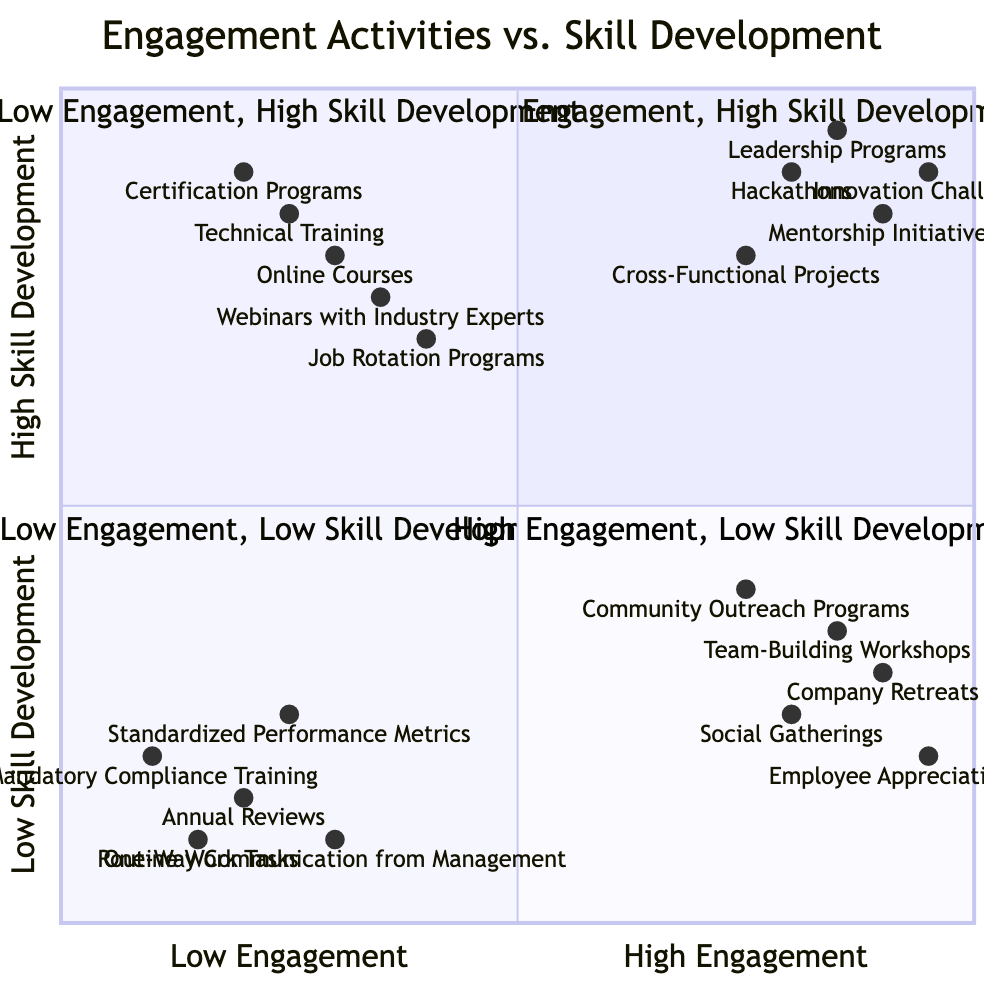Which activities are in the "High Engagement, High Skill Development" quadrant? The diagram indicates that the activities listed in this quadrant include Hackathons, Leadership Programs, Mentorship Initiatives, Innovation Challenges, and Cross-Functional Projects.
Answer: Hackathons, Leadership Programs, Mentorship Initiatives, Innovation Challenges, Cross-Functional Projects How many activities are in the "Low Engagement, Low Skill Development" quadrant? By counting the activities in this quadrant from the diagram, we find there are five activities: Mandatory Compliance Training, Routine Work Tasks, Annual Reviews, Standardized Performance Metrics, and One-Way Communication from Management.
Answer: 5 Which quadrant contains "Employee Appreciation Events"? Looking at the diagram, "Employee Appreciation Events" is listed under the "High Engagement, Low Skill Development" quadrant.
Answer: High Engagement, Low Skill Development What is the main focus of the "Low Engagement, High Skill Development" quadrant? The focus of this quadrant is on providing skill-enhancing opportunities without engaging employees, such as Online Courses, Certification Programs, Technical Training, Webinars with Industry Experts, and Job Rotation Programs.
Answer: Skill enhancement without engagement How do "Hackathons" and "Webinars with Industry Experts" compare in terms of engagement? In the diagram, "Hackathons" are positioned in the "High Engagement, High Skill Development" quadrant, whereas "Webinars with Industry Experts" are in the "Low Engagement, High Skill Development." This indicates that Hackathons are more engaging than Webinars with Industry Experts.
Answer: Hackathons are more engaging What is the lowest skill development activity in the diagram? The activity with the lowest position related to skill development is "Routine Work Tasks" as it resides in the "Low Engagement, Low Skill Development" quadrant, indicating minimal effort towards skill enhancement.
Answer: Routine Work Tasks How many activities are categorized as having High Engagement and High Skill Development? According to the diagram, there are five activities identified as having both High Engagement and High Skill Development, which are Hackathons, Leadership Programs, Mentorship Initiatives, Innovation Challenges, and Cross-Functional Projects.
Answer: 5 What is the key difference between the "High Engagement, Low Skill Development" and "Low Engagement, High Skill Development" quadrants? The key difference is that the former focuses on activities that boost employee morale and engagement but don't enhance skills, while the latter features activities aimed at enhancing skills but lacks engagement.
Answer: Morale vs. Skill enhancement Which quadrant contains the most well-rounded activities? The "High Engagement, High Skill Development" quadrant contains the most well-rounded activities as they enhance both employee skills and engagement simultaneously.
Answer: High Engagement, High Skill Development 